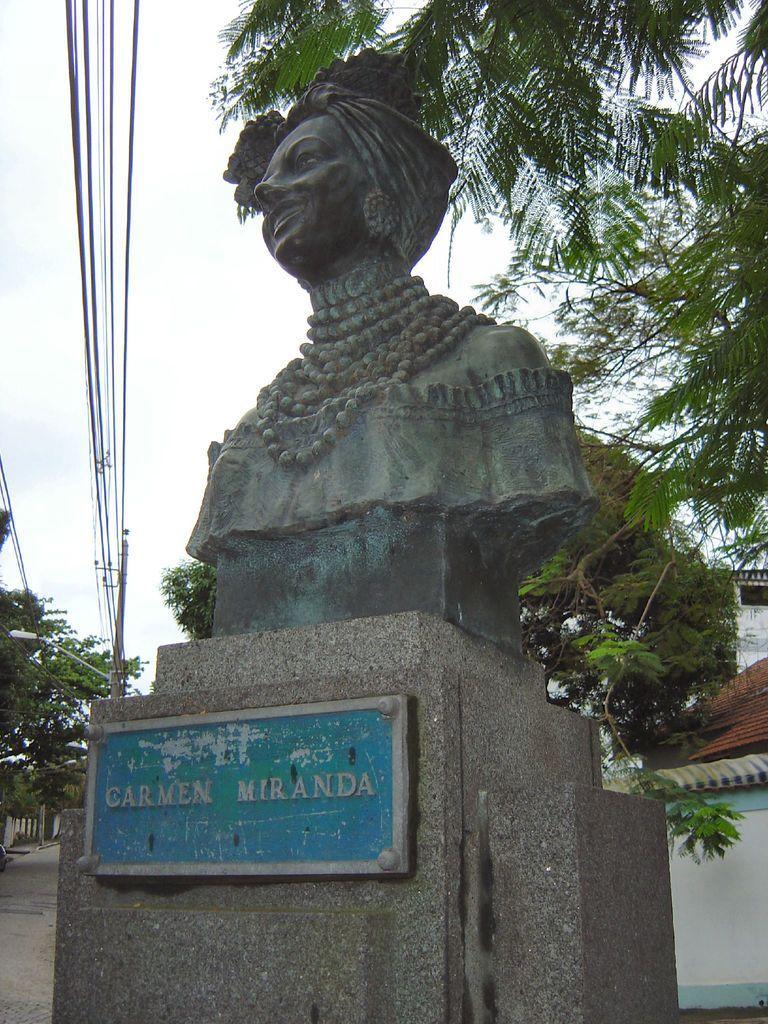Describe this image in one or two sentences. In this image, we can see the statue of a person and there is also some text written in blue color below the statue. There is also a pole with some wires passing through it and there is a road and there are some trees which are green in color and there is a house at the back of the statue. 